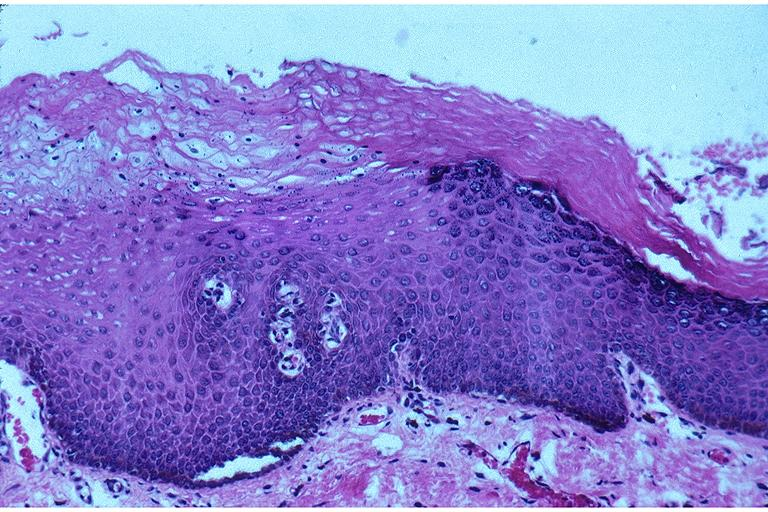where is this?
Answer the question using a single word or phrase. Oral 